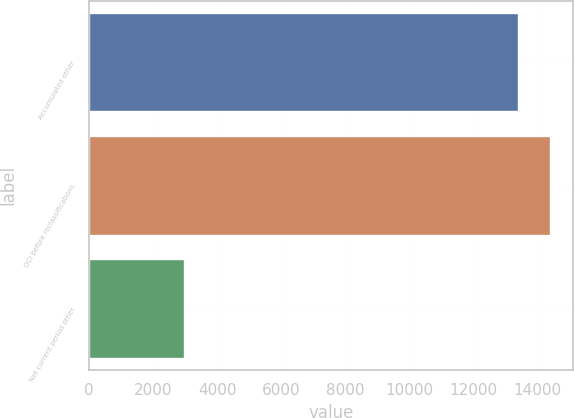Convert chart to OTSL. <chart><loc_0><loc_0><loc_500><loc_500><bar_chart><fcel>Accumulated other<fcel>OCI before reclassifications<fcel>Net current period other<nl><fcel>13374.6<fcel>14378.2<fcel>2970<nl></chart> 